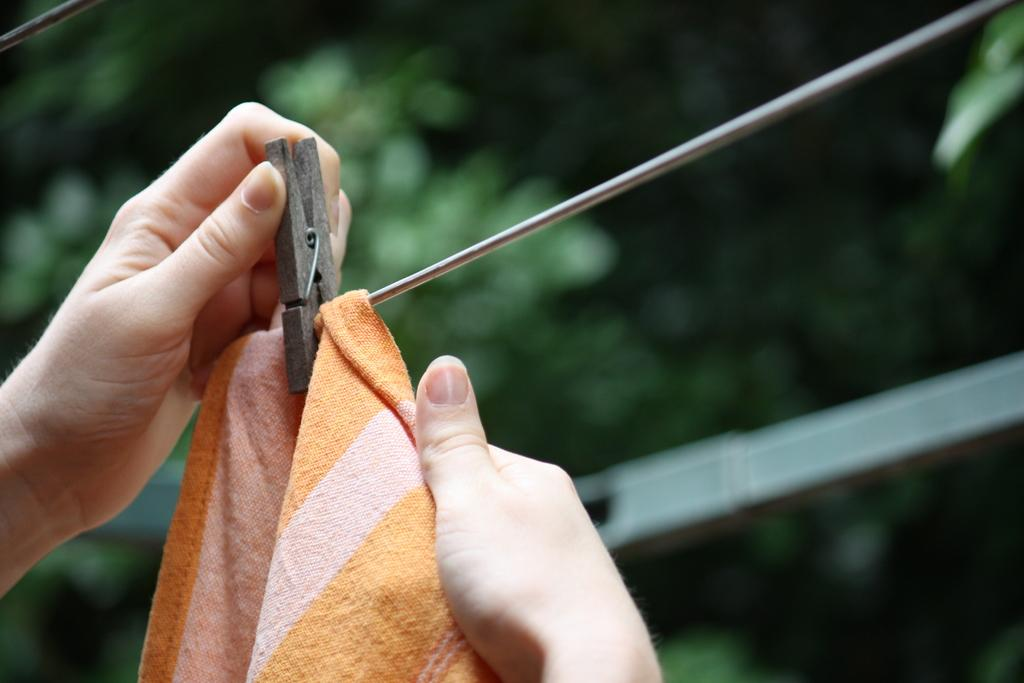What is the person holding in the image? The person's hands are holding a clip in the image. What is the clip attached to? The clip is attached to a cloth in the image. How is the cloth positioned? The cloth is placed on a rope in the image. What can be seen in the background of the image? Few leaves are visible in the background of the image. What type of plant is growing in space in the image? There is no plant growing in space in the image; it features a person holding a clip attached to a cloth on a rope. Can you describe the carriage used by the person in the image? There is no carriage present in the image; it only shows a person holding a clip attached to a cloth on a rope. 